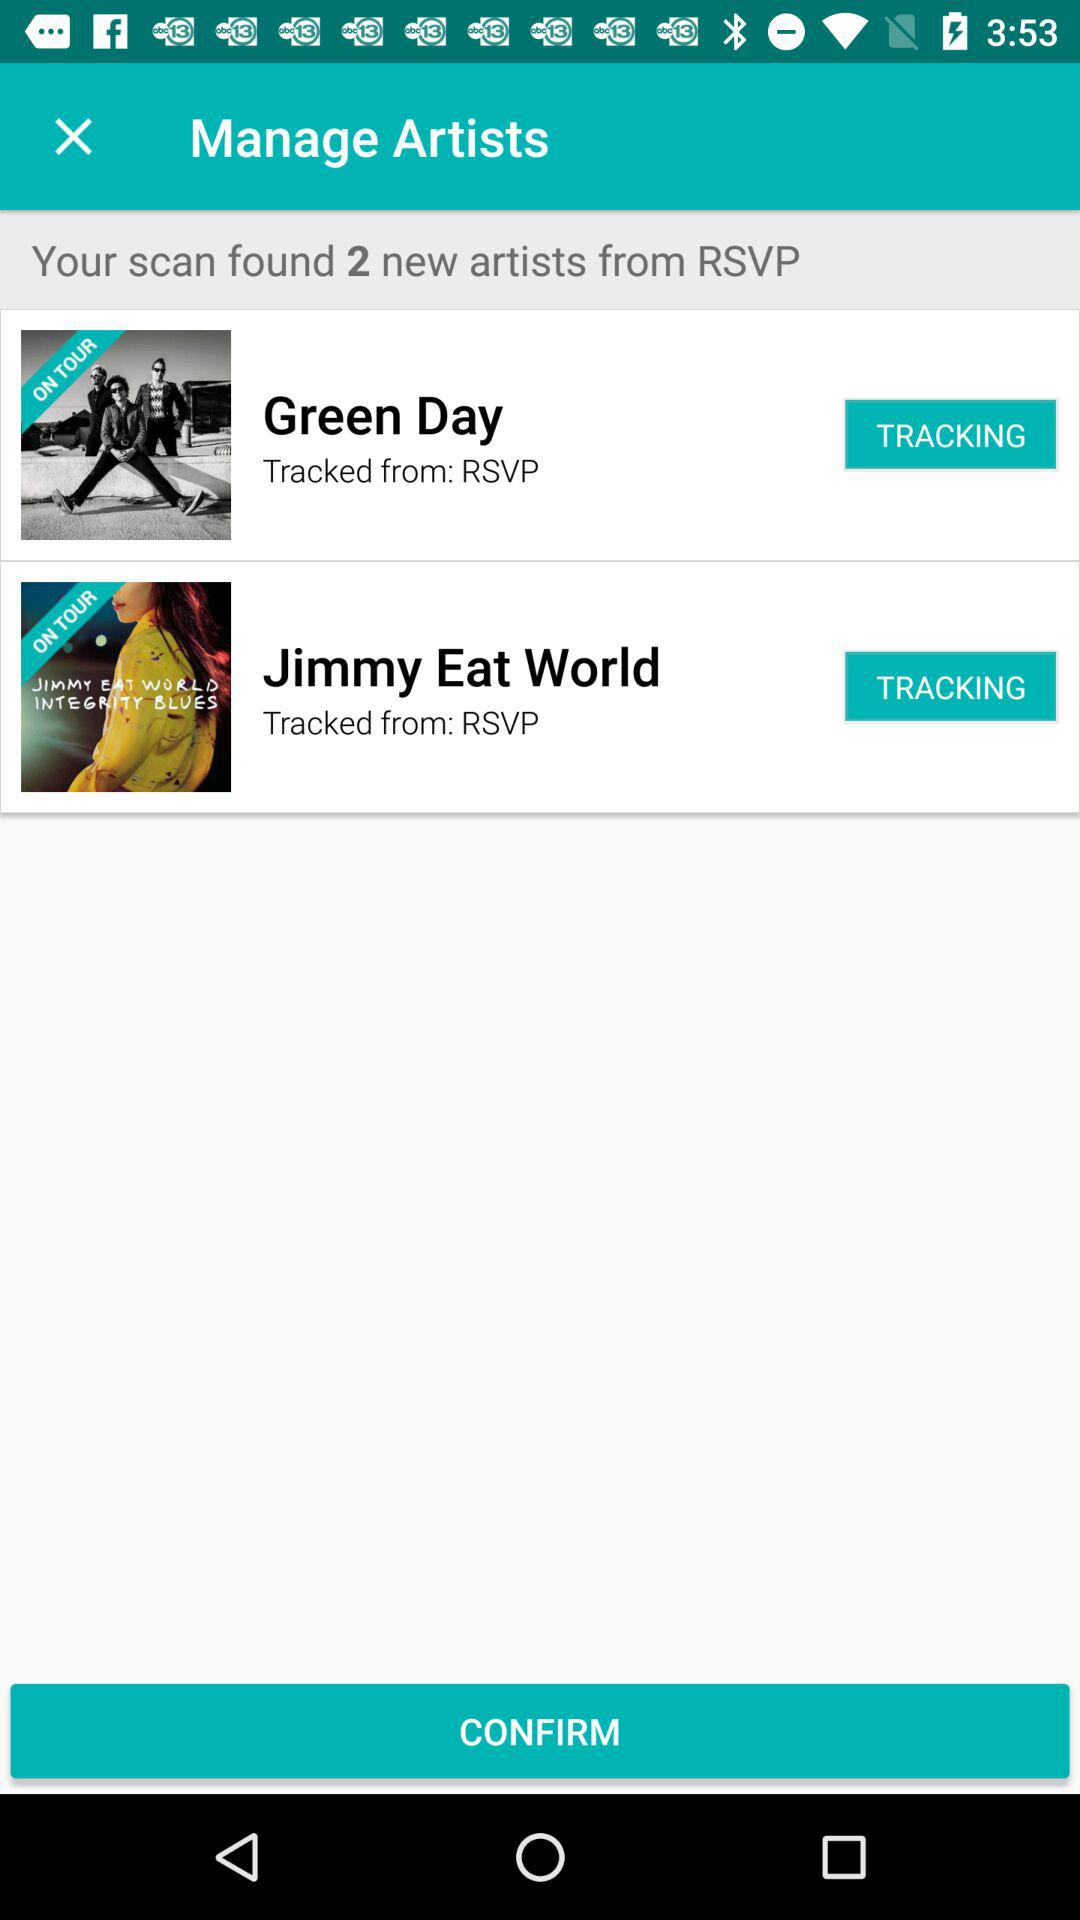Can you tell me more about the 'Integrity Blues' album mentioned under Jimmy Eat World? Certainly! 'Integrity Blues' is an album by Jimmy Eat World. It appears to be associated with the artist in the app, possibly indicating that it is their latest or currently promoted release. Fans might use such a tracking app to stay updated on news, tour dates, and releases related to the albums they are interested in. 